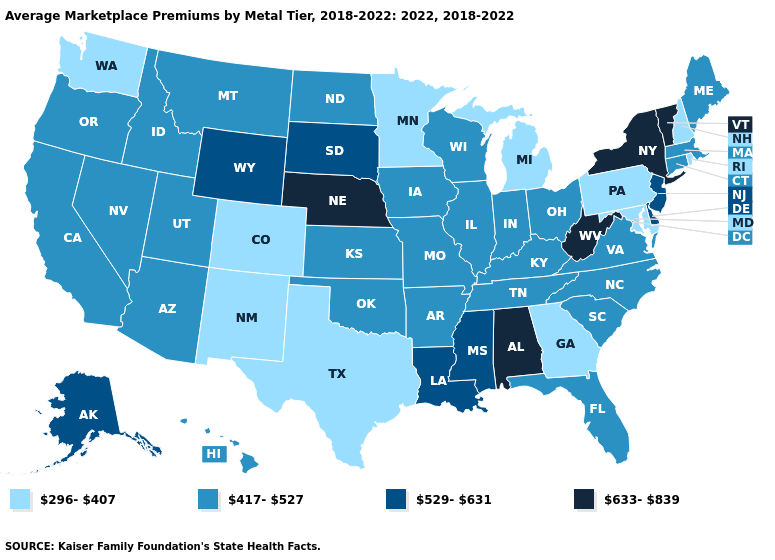Name the states that have a value in the range 633-839?
Keep it brief. Alabama, Nebraska, New York, Vermont, West Virginia. What is the value of Tennessee?
Write a very short answer. 417-527. Does Texas have the lowest value in the USA?
Keep it brief. Yes. Does the map have missing data?
Keep it brief. No. Does Idaho have a higher value than Georgia?
Keep it brief. Yes. What is the lowest value in the USA?
Answer briefly. 296-407. Does Alaska have the same value as Delaware?
Concise answer only. Yes. Among the states that border Michigan , which have the lowest value?
Keep it brief. Indiana, Ohio, Wisconsin. What is the value of Pennsylvania?
Short answer required. 296-407. What is the value of California?
Keep it brief. 417-527. Does Arkansas have the same value as Michigan?
Write a very short answer. No. Does the map have missing data?
Give a very brief answer. No. How many symbols are there in the legend?
Answer briefly. 4. Does Alabama have a higher value than West Virginia?
Be succinct. No. Does Wyoming have the highest value in the USA?
Give a very brief answer. No. 